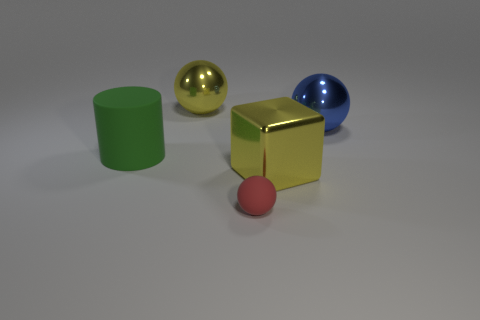What number of cyan objects are either large rubber objects or spheres?
Provide a succinct answer. 0. Are there an equal number of large green rubber things that are on the left side of the green cylinder and gray objects?
Your answer should be compact. Yes. What number of things are either metal cubes or big things behind the large yellow shiny cube?
Offer a terse response. 4. Is there a yellow sphere that has the same material as the large blue sphere?
Your response must be concise. Yes. There is a small object that is the same shape as the big blue metal thing; what is its color?
Ensure brevity in your answer.  Red. Is the material of the big yellow ball the same as the tiny red sphere that is in front of the green cylinder?
Ensure brevity in your answer.  No. What shape is the large yellow shiny object that is in front of the large yellow object behind the big rubber cylinder?
Keep it short and to the point. Cube. There is a matte thing in front of the green cylinder; is it the same size as the big cylinder?
Offer a terse response. No. How many other objects are there of the same shape as the green rubber thing?
Offer a very short reply. 0. There is a metal object that is on the left side of the red ball; does it have the same color as the block?
Offer a very short reply. Yes. 